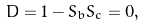<formula> <loc_0><loc_0><loc_500><loc_500>D = 1 - S _ { b } S _ { c } = 0 ,</formula> 